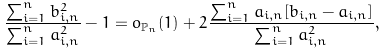Convert formula to latex. <formula><loc_0><loc_0><loc_500><loc_500>\frac { \sum _ { i = 1 } ^ { n } b ^ { 2 } _ { i , n } } { \sum _ { i = 1 } ^ { n } a ^ { 2 } _ { i , n } } - 1 = o _ { \mathbb { P } _ { n } } ( 1 ) + 2 \frac { \sum _ { i = 1 } ^ { n } a _ { i , n } [ b _ { i , n } - a _ { i , n } ] } { \sum _ { i = 1 } ^ { n } a ^ { 2 } _ { i , n } } ,</formula> 